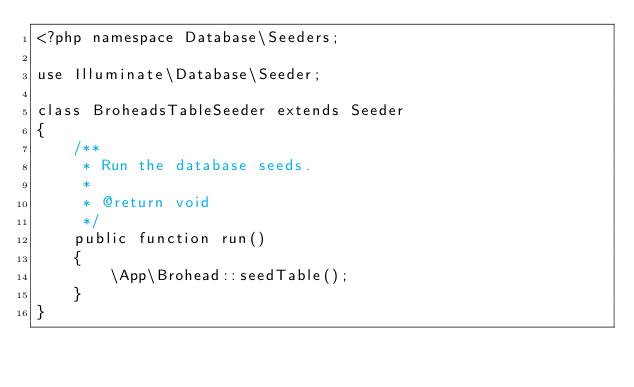<code> <loc_0><loc_0><loc_500><loc_500><_PHP_><?php namespace Database\Seeders;

use Illuminate\Database\Seeder;

class BroheadsTableSeeder extends Seeder
{
    /**
     * Run the database seeds.
     *
     * @return void
     */
    public function run()
    {
        \App\Brohead::seedTable();
    }
}
</code> 